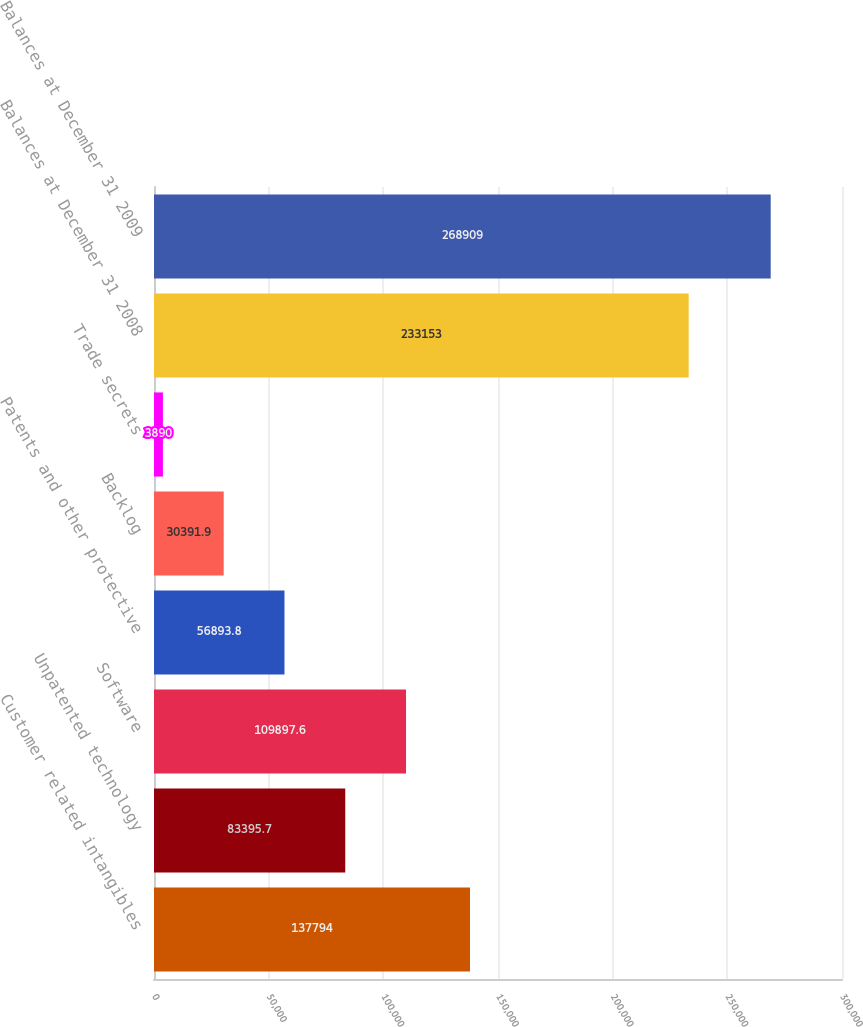Convert chart to OTSL. <chart><loc_0><loc_0><loc_500><loc_500><bar_chart><fcel>Customer related intangibles<fcel>Unpatented technology<fcel>Software<fcel>Patents and other protective<fcel>Backlog<fcel>Trade secrets<fcel>Balances at December 31 2008<fcel>Balances at December 31 2009<nl><fcel>137794<fcel>83395.7<fcel>109898<fcel>56893.8<fcel>30391.9<fcel>3890<fcel>233153<fcel>268909<nl></chart> 